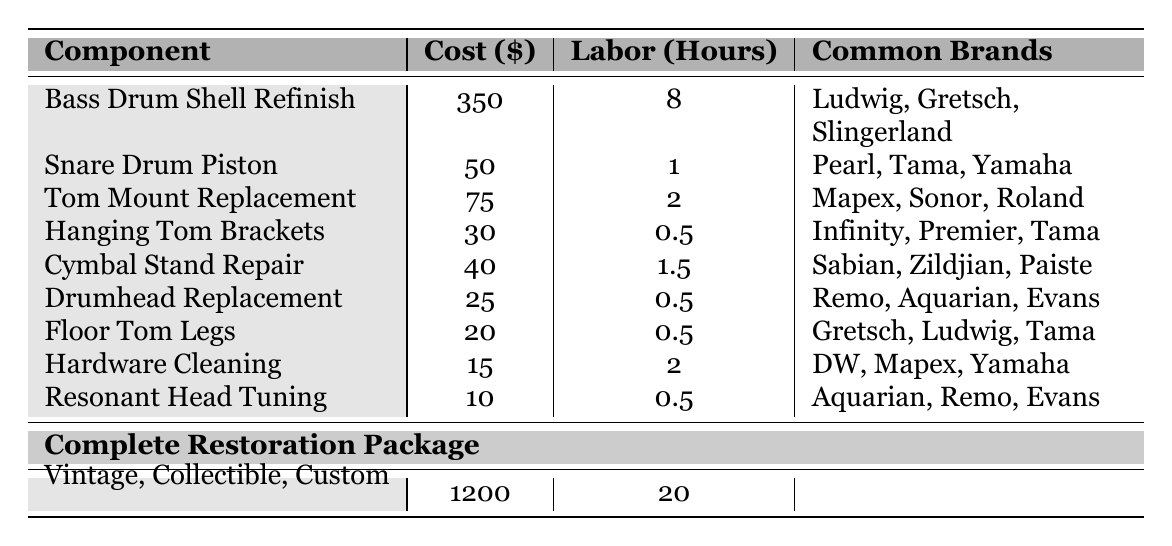What is the cost of the Bass Drum Shell Refinish? The table shows that the cost for the Bass Drum Shell Refinish is listed in the second column, which is $350.
Answer: $350 How many hours of labor are required for a Complete Restoration Package? Looking at the table, the Complete Restoration Package is in the last row of the labor time column, which states 20 hours.
Answer: 20 hours Which component has the lowest restoration cost? From the cost column, we can identify the values and see that the lowest cost is for "Resonant Head Tuning," which is $10.
Answer: $10 What is the total cost of refinishing the Bass Drum Shell and replacing the Snare Drum Piston? We add the costs from the respective rows: Bass Drum Shell Refinish is $350, and Snare Drum Piston is $50. Therefore, the total cost is 350 + 50 = $400.
Answer: $400 Is the labor time for the Hanging Tom Brackets more than one hour? The labor time for Hanging Tom Brackets is shown as 0.5 hours, which is less than one hour. Thus, the answer is no.
Answer: No What is the average cost of the components listed in the table (excluding the Complete Restoration Package)? First, we find the costs of the individual components (excluding the complete package) and sum them up: 350 + 50 + 75 + 30 + 40 + 25 + 20 + 15 + 10 = 615. There are 9 components, so average cost is 615 / 9 ≈ 68.33.
Answer: $68.33 Which common brands are associated with the Snare Drum Piston? The Snare Drum Piston's row in the table lists the common brands as Pearl, Tama, and Yamaha, which we can directly refer to from that row.
Answer: Pearl, Tama, Yamaha If you were to restore both a Floor Tom Legs and Hardware Cleaning, how much would it cost in total? Adding the costs for Floor Tom Legs ($20) and Hardware Cleaning ($15) gives us $20 + $15 = $35.
Answer: $35 Do all components have a listed labor time of at least one hour? Reviewing the labor time for components reveals that both Drumhead Replacement and Floor Tom Legs have labor times less than one hour (0.5 hours), so the answer is no.
Answer: No What is the difference in labor time between the Complete Restoration Package and Cymbal Stand Repair? The Complete Restoration Package requires 20 hours and Cymbal Stand Repair requires 1.5 hours. The difference is calculated as 20 - 1.5 = 18.5 hours.
Answer: 18.5 hours 